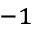<formula> <loc_0><loc_0><loc_500><loc_500>^ { - 1 }</formula> 